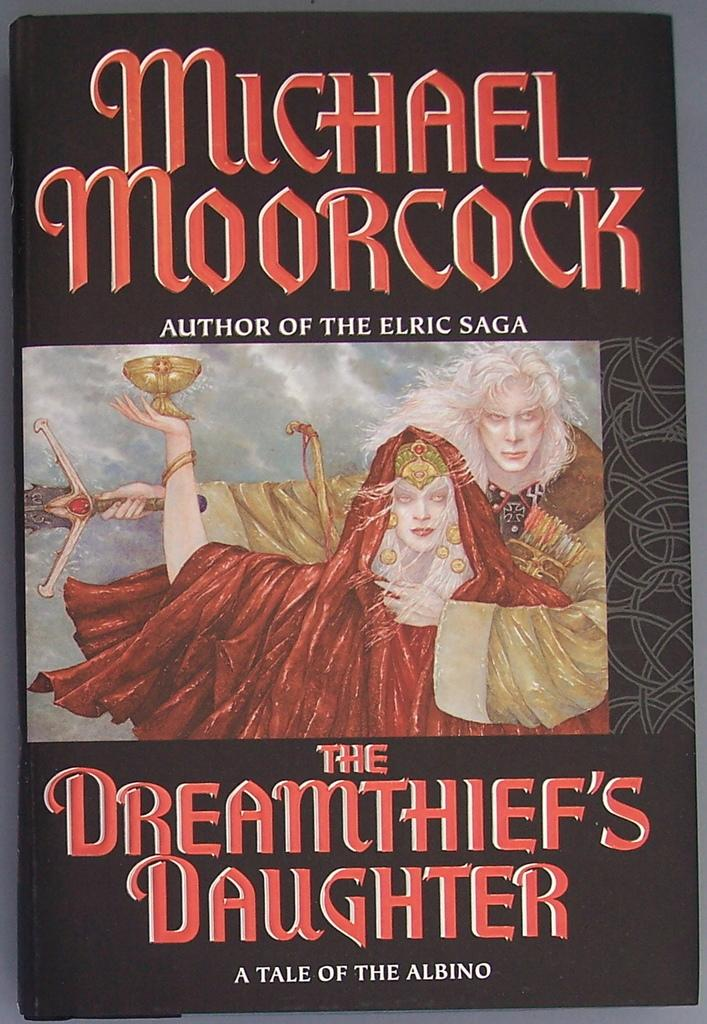What is the main subject of the image? The main subject of the image is the cover page of a book. What can be seen on the cover page? The cover page has a picture of two persons. Is there any text on the cover page? Yes, there is text is written on the cover page. What type of bird can be seen flying in the image? There is no bird present in the image; it features the cover page of a book with a picture of two persons and text. Can you tell me how many owls are depicted on the cover page? There are no owls depicted on the cover page; it only has a picture of two persons and text. 